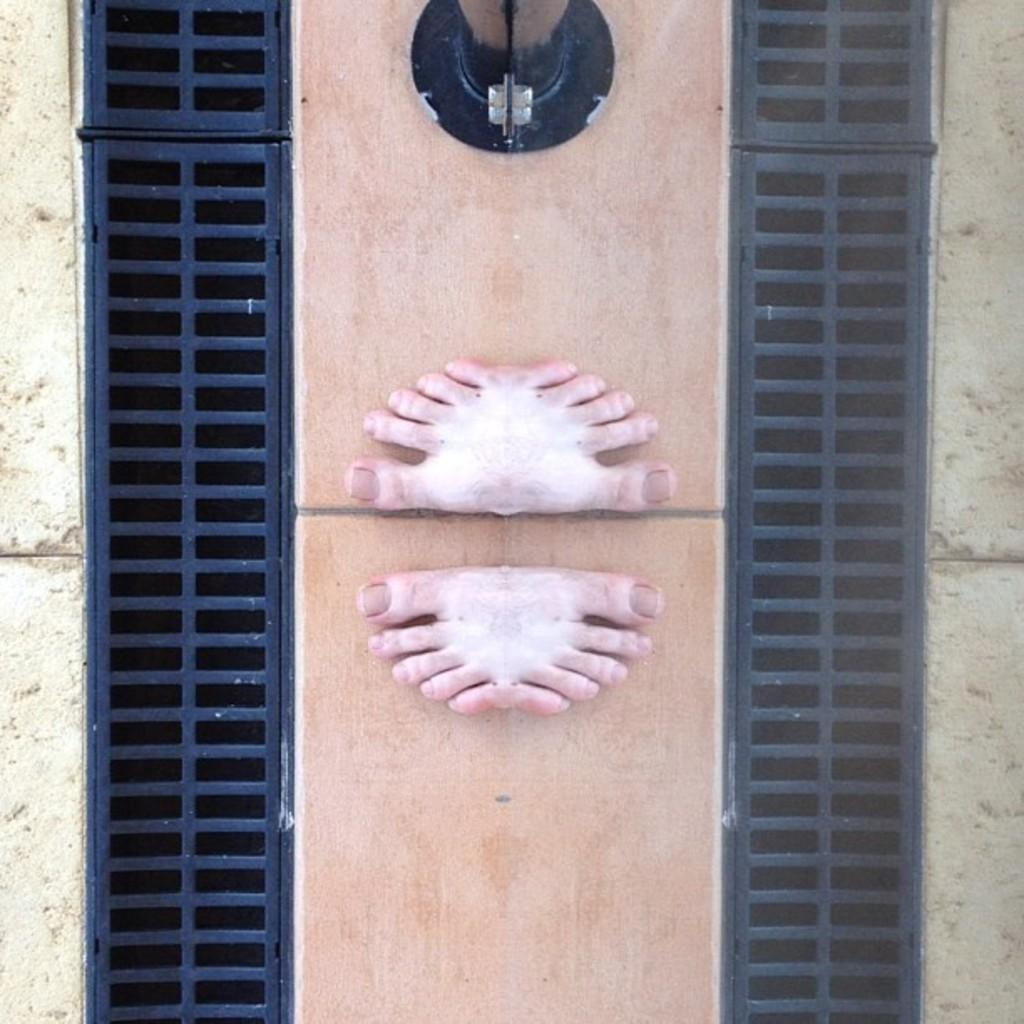What part of a person is visible in the image? There is a foot of a person in the image. What can be seen in the background of the image? There is a metal mesh and a pole in the background of the image. How deep is the hole in the image? There is no hole present in the image. 